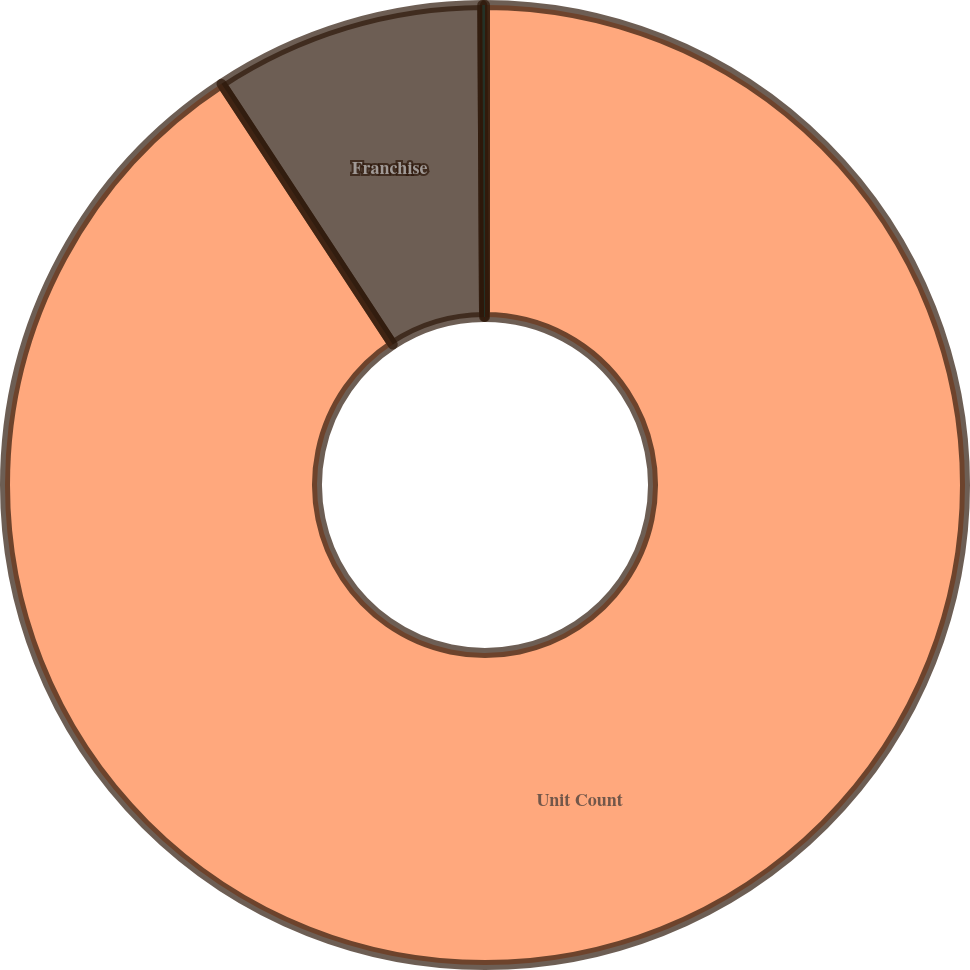Convert chart. <chart><loc_0><loc_0><loc_500><loc_500><pie_chart><fcel>Unit Count<fcel>Franchise<fcel>Company-owned<nl><fcel>90.75%<fcel>9.16%<fcel>0.09%<nl></chart> 